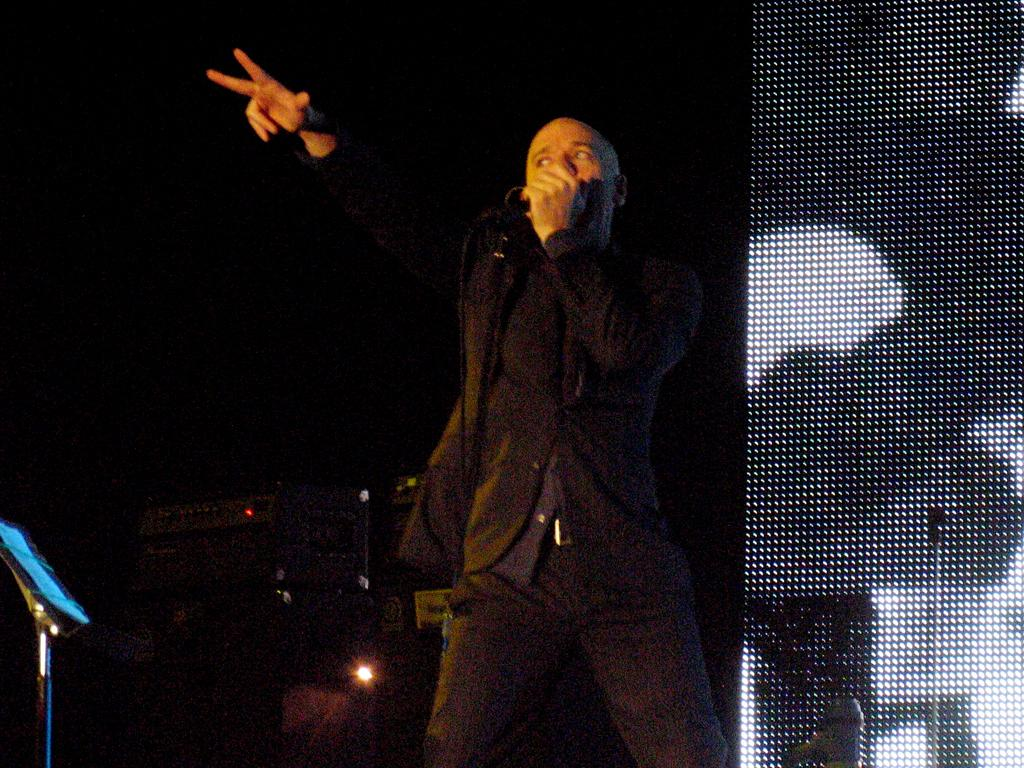What is the main subject of the image? There is a man in the image. What is the man doing in the image? The man is standing in the image. What object is the man holding in the image? The man is holding a microphone in the image. What can be seen in the background of the image? There are electrical devices in the background of the image. How many ducks are visible in the image? There are no ducks present in the image. What is the man's digestion process like in the image? There is no information about the man's digestion process in the image. 